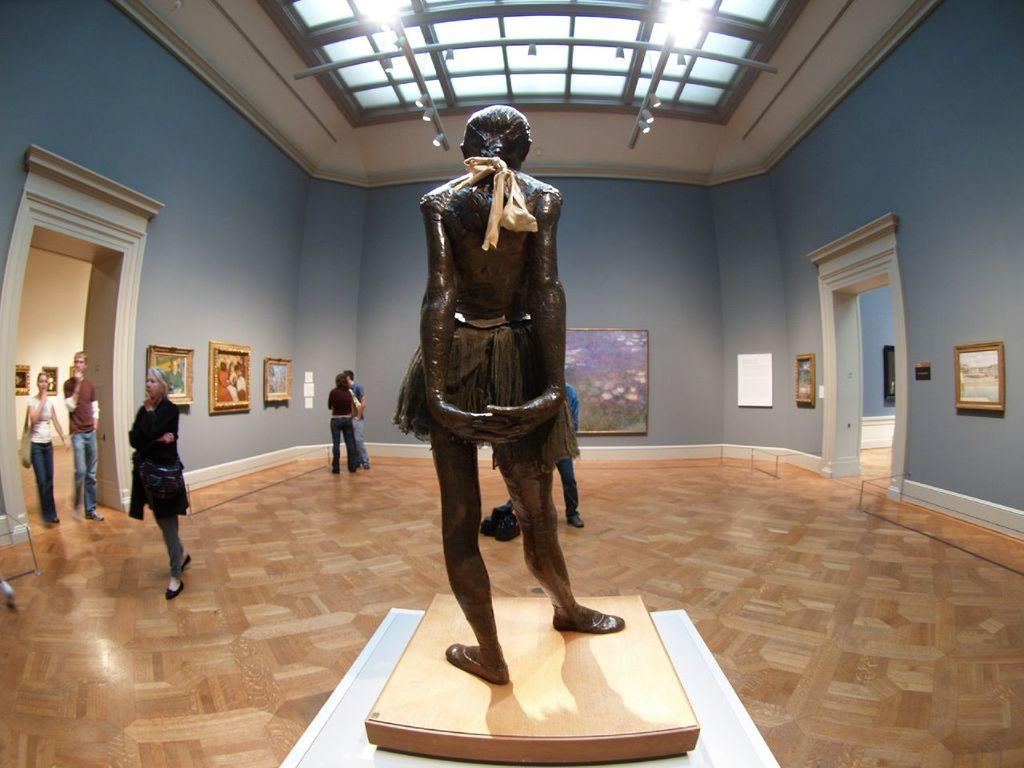What is the main subject in the image? There is a sculpture in the image. What else can be seen in the image besides the sculpture? There are groups of persons standing on the floor, a wall, photo frames on the wall, lights, and a door. Can you describe the wall in the image? There is a wall in the image with photo frames on it. What type of lighting is visible in the image? There are lights visible in the image. How many bikes are parked next to the sculpture in the image? There are no bikes present in the image. What type of pancake is being served to the persons standing on the floor in the image? There is no pancake present in the image. 